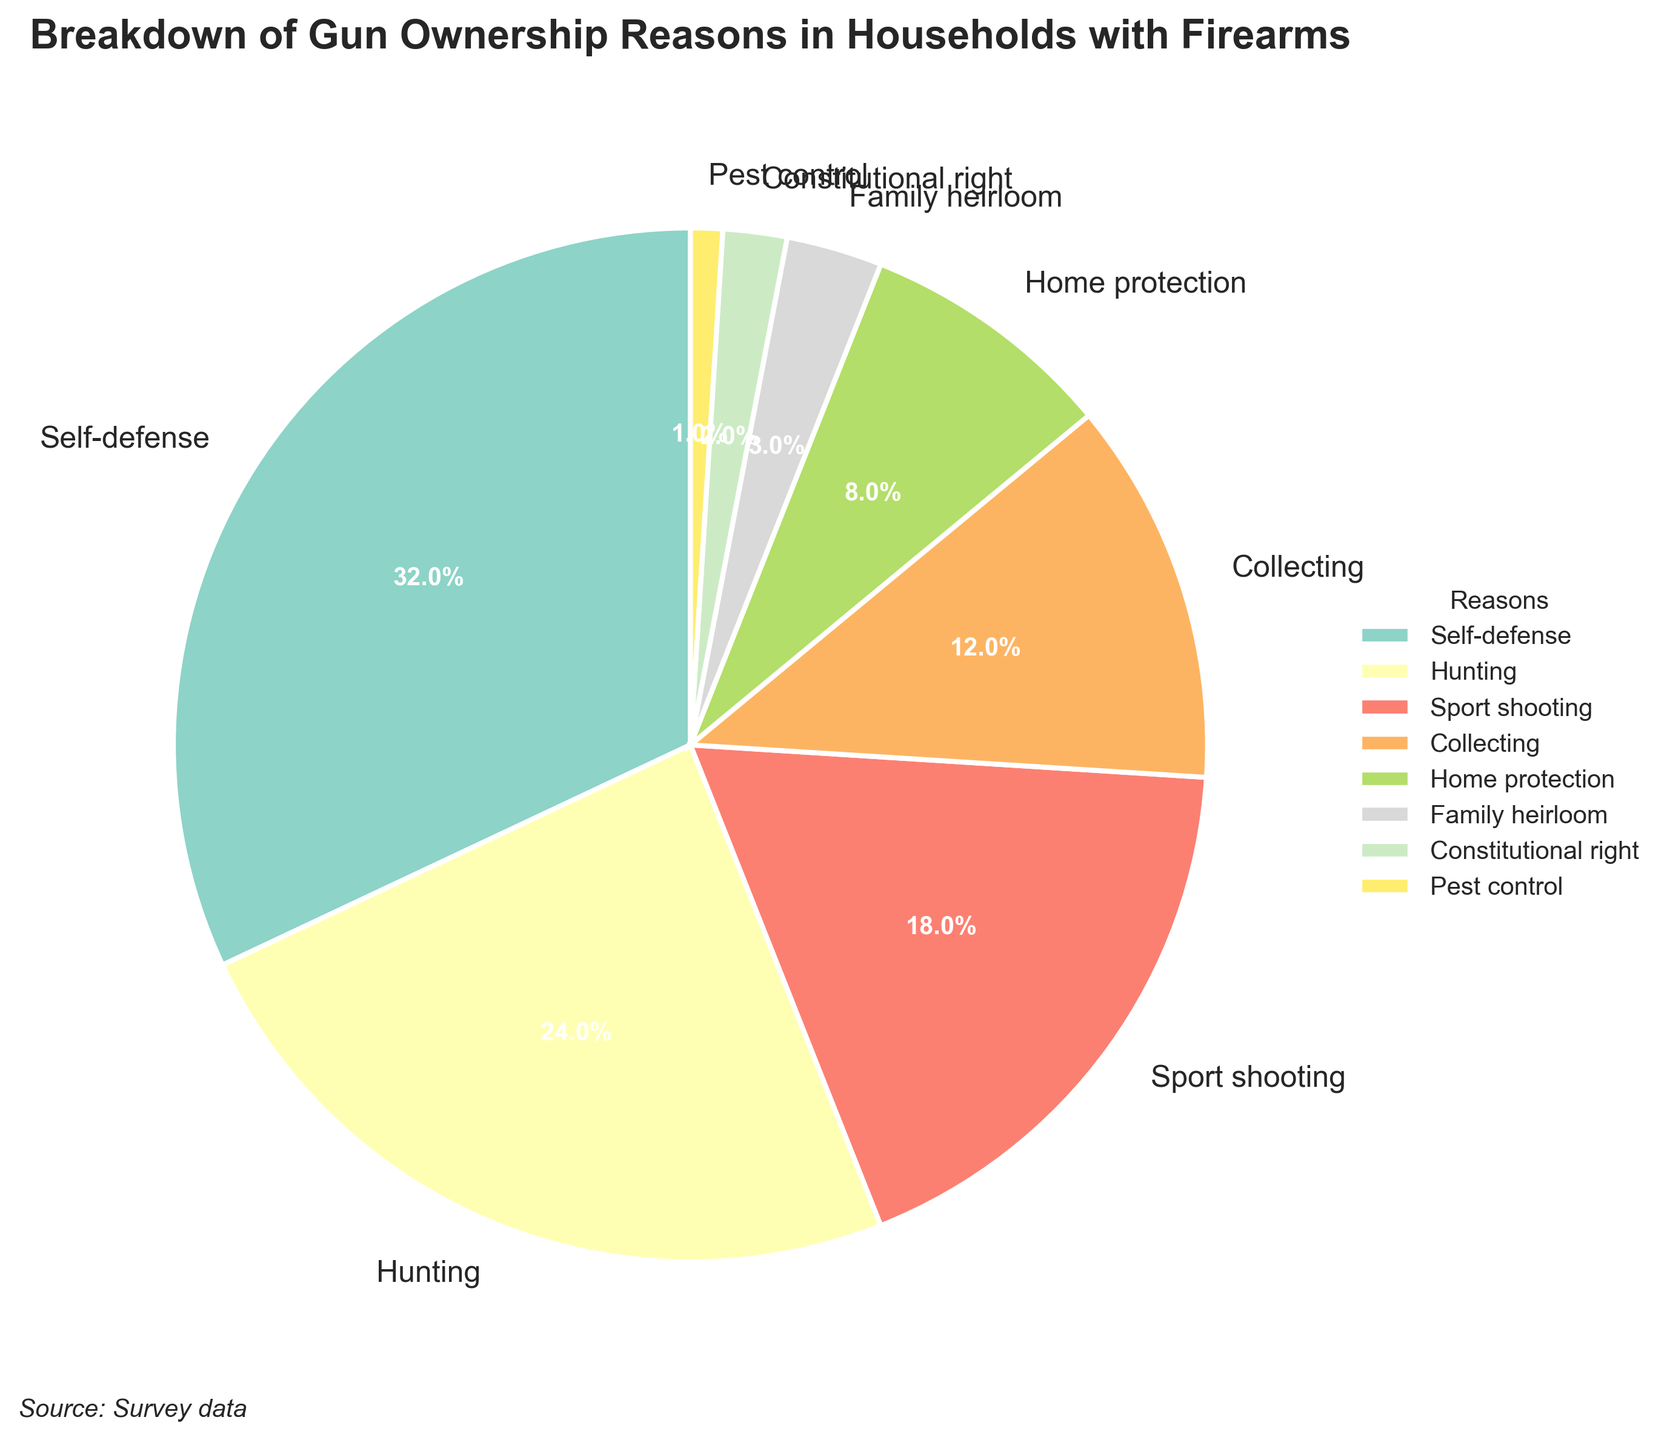What is the most common reason for gun ownership according to the figure? By looking at the figure, we can see that 'Self-defense' has the largest pie slice with the highest percentage of 32%.
Answer: Self-defense What is the combined percentage of households that own guns for hunting and sport shooting? From the figure, 'Hunting' is 24% and 'Sport shooting' is 18%. Summing them up yields 24% + 18% = 42%.
Answer: 42% Which reason has the least percentage of gun ownership? By observing the smallest pie slice, we can see that 'Pest control' has the smallest percentage of 1%.
Answer: Pest control What is the difference in percentage between households that own guns for self-defense and those that own them for home protection? The percentage for 'Self-defense' is 32% and for 'Home protection' is 8%. The difference is 32% - 8% = 24%.
Answer: 24% Do more households own guns for collecting or as a family heirloom? By comparing the sizes of the pie slices, 'Collecting' has a larger percentage (12%) compared to 'Family heirloom' (3%).
Answer: Collecting What is the total percentage of households that own guns for self-defense, home protection, and hunting combined? According to the figure, 'Self-defense' is 32%, 'Home protection' is 8%, and 'Hunting' is 24%. Summing these percentages gives 32% + 8% + 24% = 64%.
Answer: 64% Which two reasons together account for just over half of the gun ownership reasons? Combining the two largest slices, 'Self-defense' (32%) and 'Hunting' (24%), totals to 32% + 24% = 56%, which is just over half (50%).
Answer: Self-defense and Hunting Are there more households that own guns for constitutional rights or pest control? By observing the figure, 'Constitutional right' accounts for 2% of gun ownership reasons, which is greater than 'Pest control' at 1%.
Answer: Constitutional right Which color is associated with the reason 'Sport shooting'? By looking at the pie chart legend, we can identify that the appropriate color for 'Sport shooting' in the figure.
Answer: [This requires looking at the color key present in the figure.] What percentage of gun ownership is related to reasons other than self-defense and hunting? Adding the other reasons: 'Sport shooting' (18%), 'Collecting' (12%), 'Home protection' (8%), 'Family heirloom' (3%), 'Constitutional right' (2%), and 'Pest control' (1%) gives 18% + 12% + 8% + 3% + 2% + 1% = 44%.
Answer: 44% 